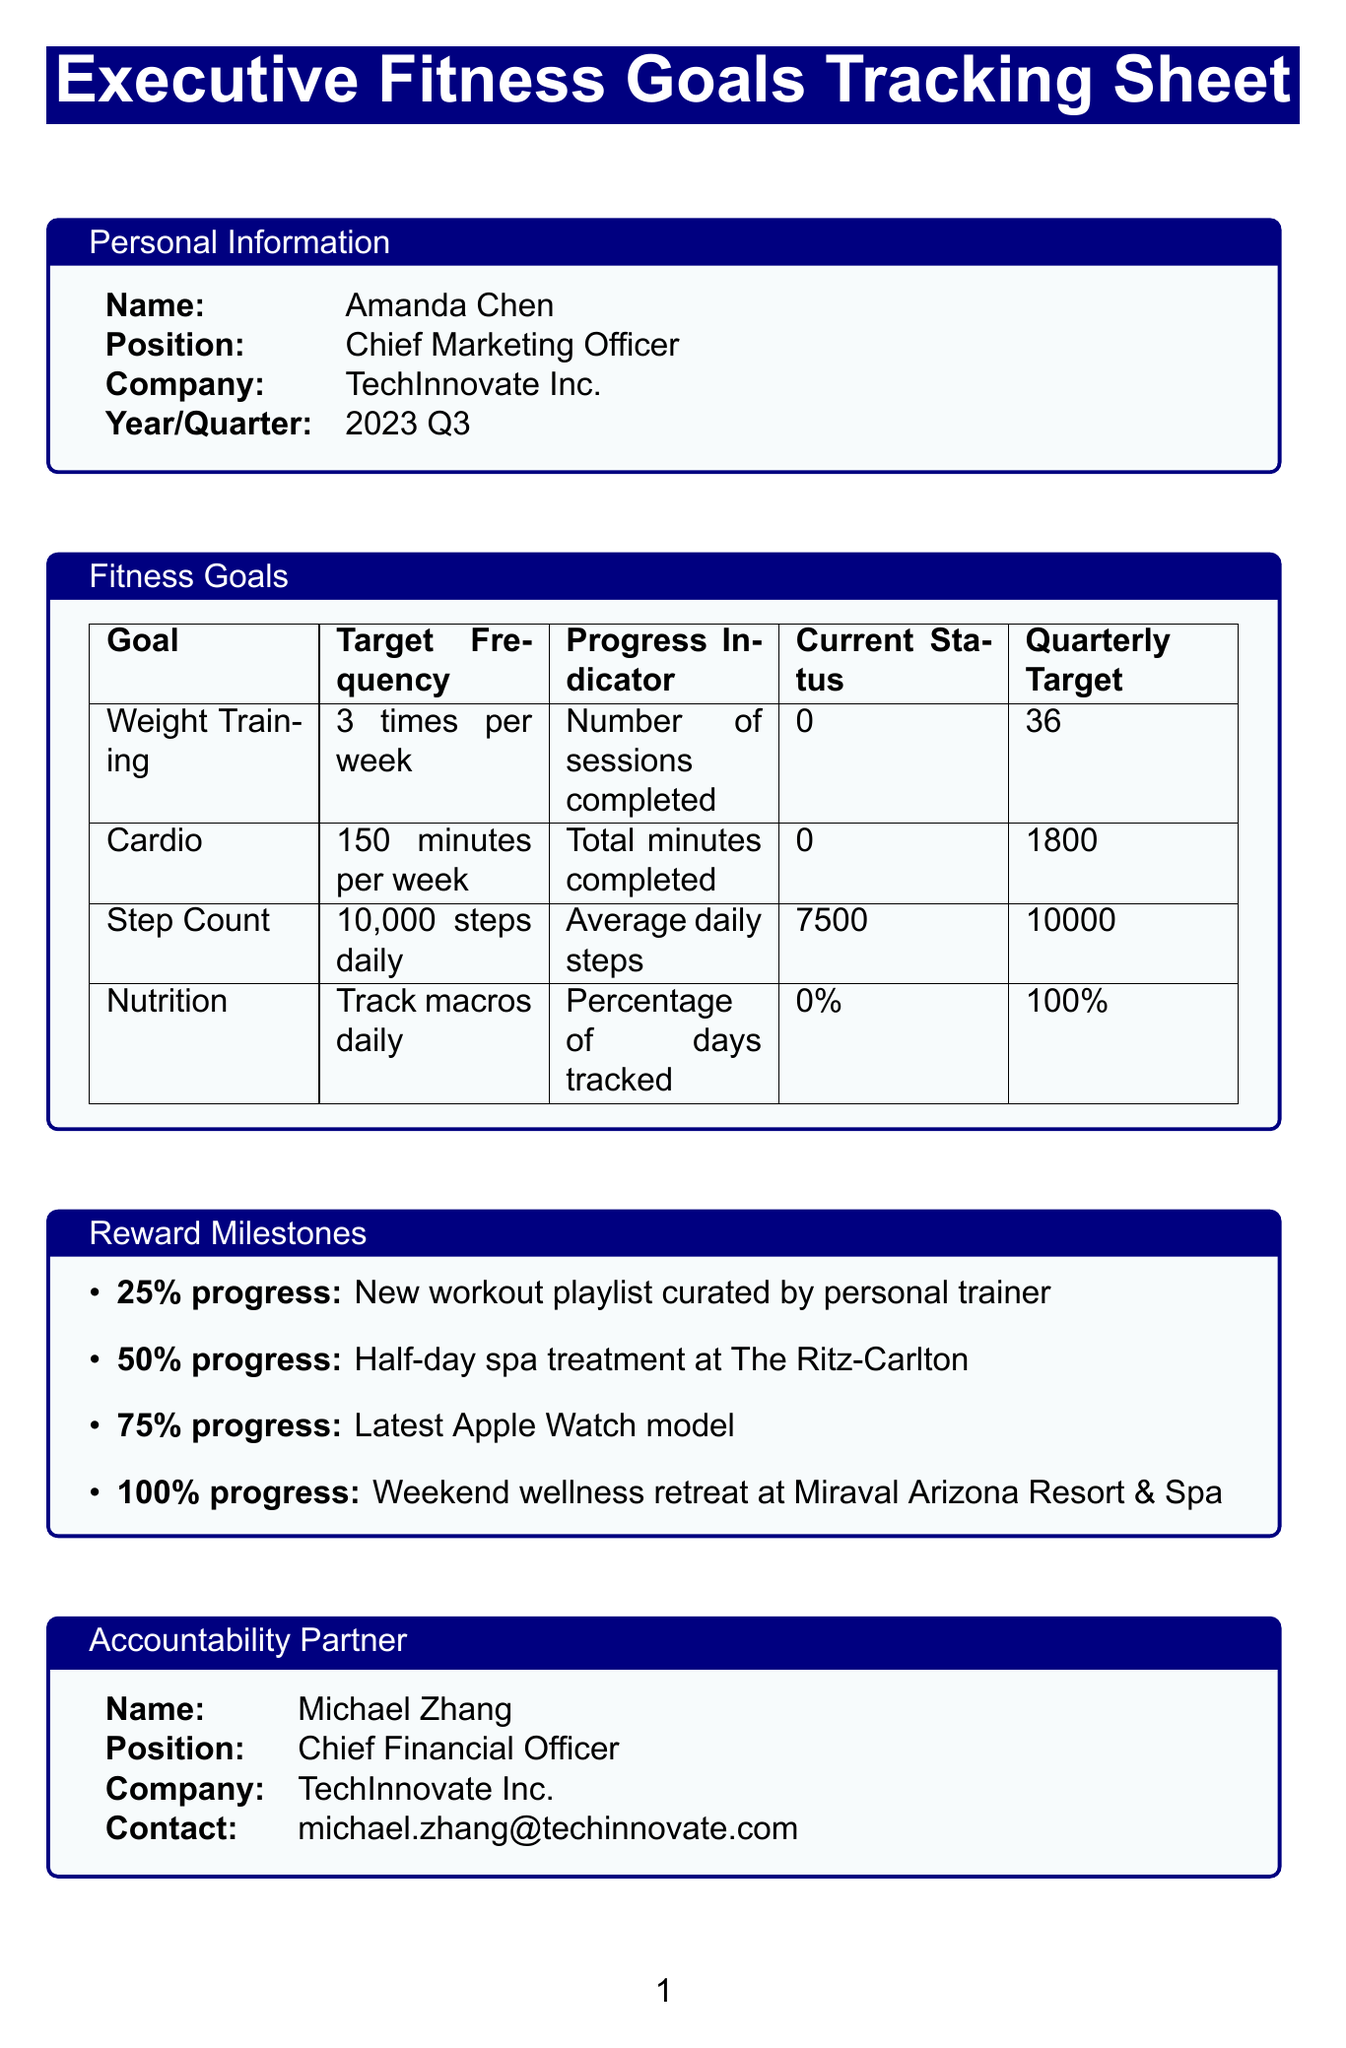What is the total quarterly target for Cardio? The quarterly target for Cardio is specified in the document as 1800 minutes.
Answer: 1800 minutes What is Amanda Chen's position? Amanda Chen is listed as the Chief Marketing Officer in the personal information section of the document.
Answer: Chief Marketing Officer What is the target frequency for Weight Training? The document states that the target frequency for Weight Training is 3 times per week.
Answer: 3 times per week What is the reward for reaching 50% progress? The reward for reaching 50% progress, according to the reward milestones, is a Half-day spa treatment at The Ritz-Carlton.
Answer: Half-day spa treatment at The Ritz-Carlton How many attendees are mentioned for the quarterly review meeting? The quarterly review meeting lists three attendees: Amanda Chen, Michael Zhang, and the HR Wellness Coordinator.
Answer: 3 